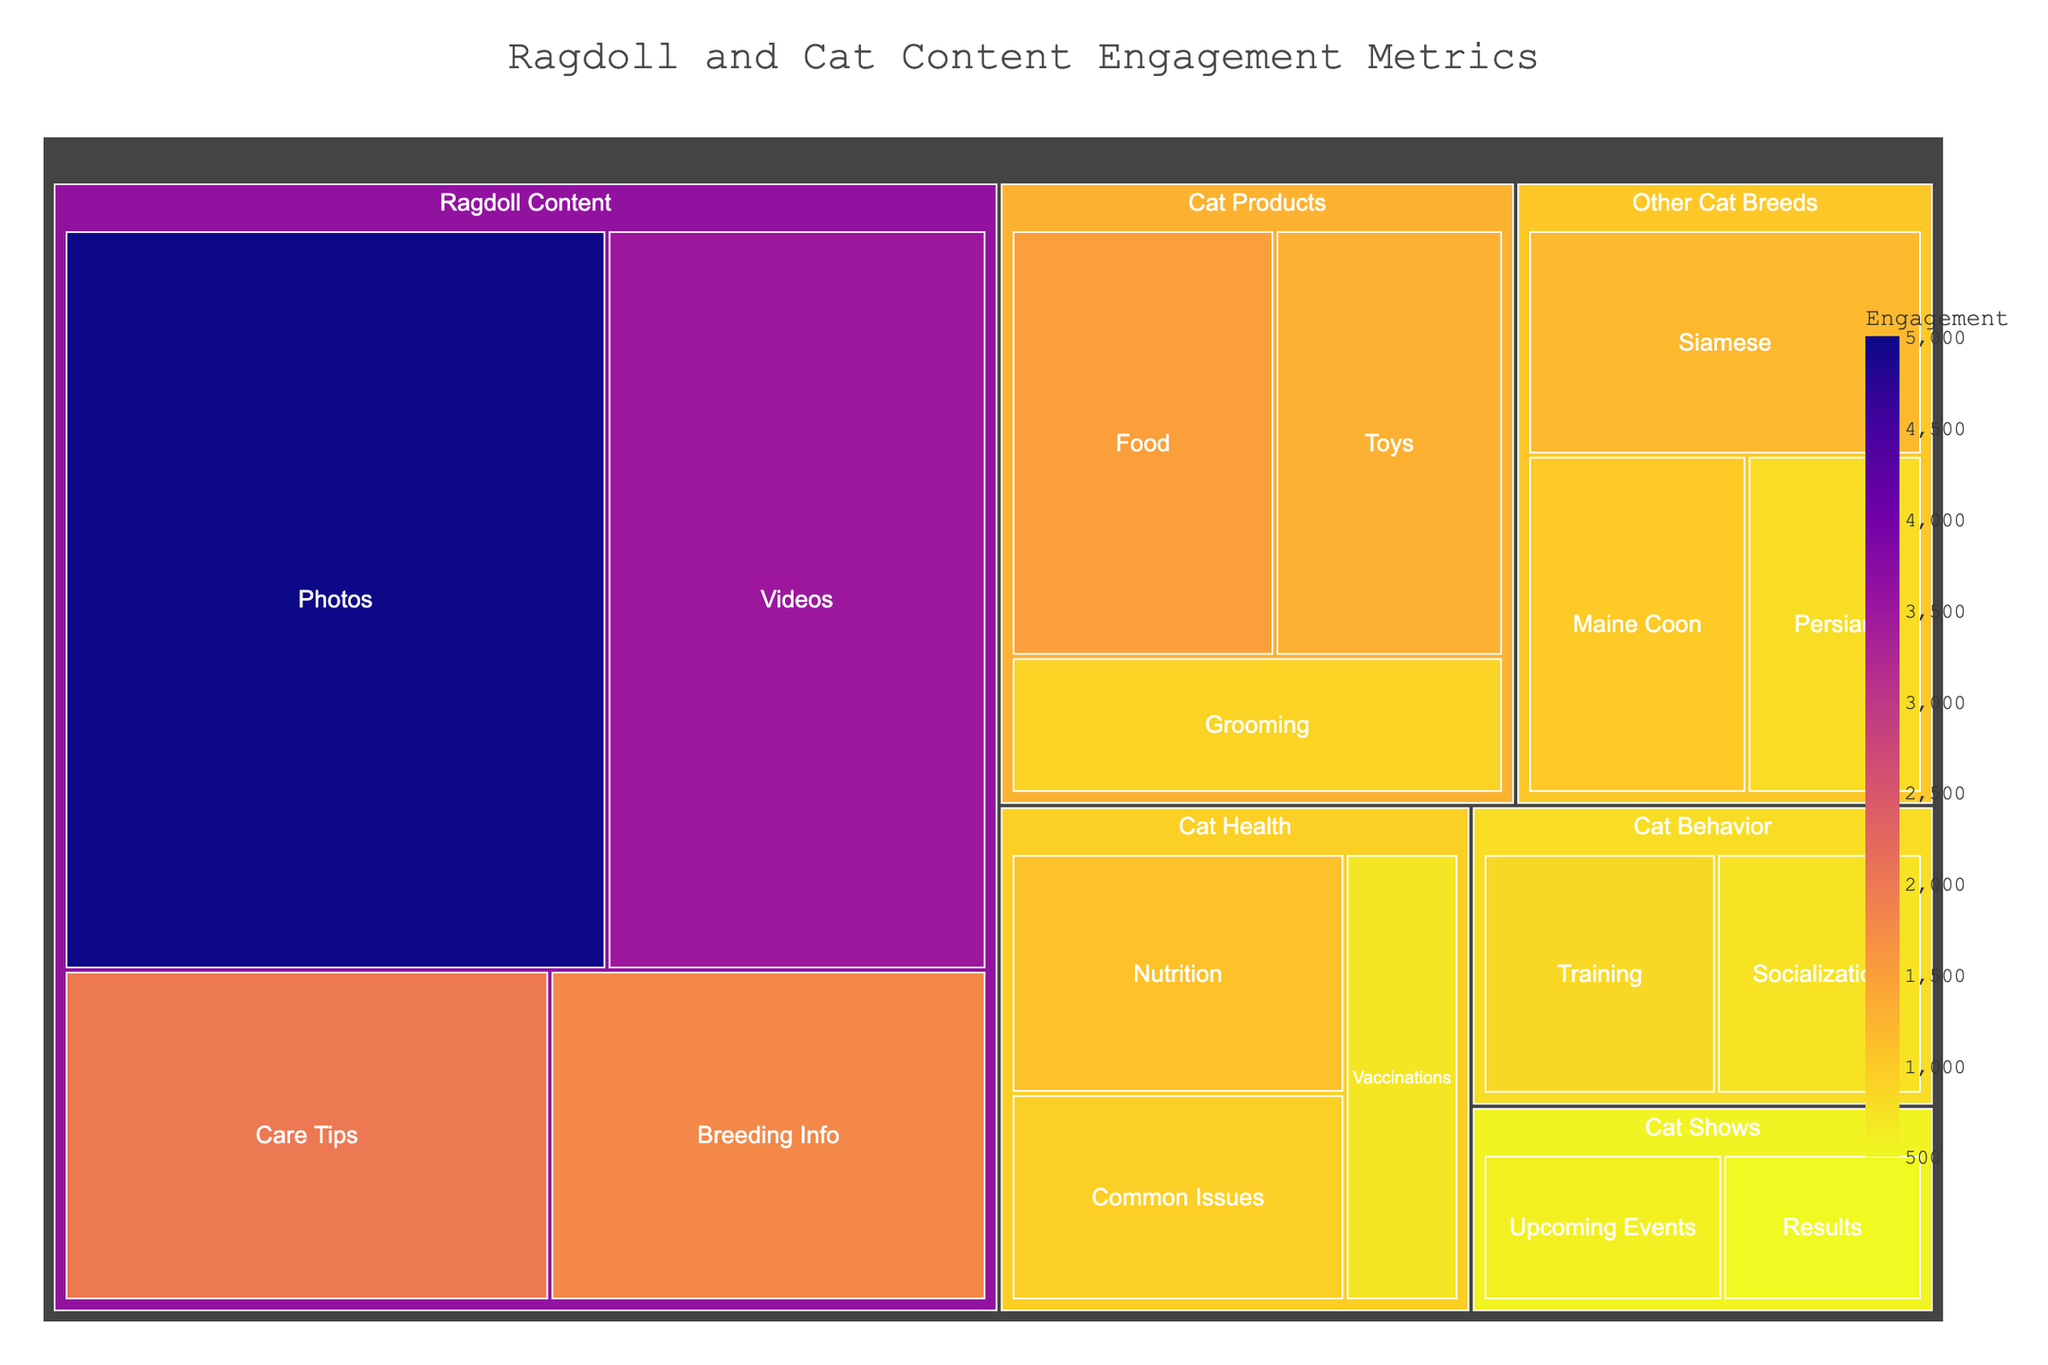What is the title of the Treemap? The title is displayed at the top of the treemap, usually in a larger font to attract attention.
Answer: Ragdoll and Cat Content Engagement Metrics Which subcategory under "Ragdoll Content" has the highest engagement? Look for the largest rectangle within the "Ragdoll Content" section, which visually represents the subcategory with the highest numerical value.
Answer: Photos What is the combined engagement for "Ragdoll Content"? Add the engagement values for all subcategories under "Ragdoll Content": 5000 (Photos) + 3500 (Videos) + 2000 (Care Tips) + 1800 (Breeding Info).
Answer: 12300 Which subcategory under "Cat Products" has the least engagement? Look for the smallest rectangle within the "Cat Products" section.
Answer: Grooming Is the engagement for "Ragdoll Content" greater than the total engagement for "Other Cat Breeds"? Sum the engagement for all subcategories in both "Ragdoll Content" and "Other Cat Breeds" and compare the totals. Ragdoll Content total is 12300 and Other Cat Breeds total is 1200 (Siamese) + 1000 (Maine Coon) + 800 (Persian) = 3000.
Answer: Yes Which category has the least overall engagement? Compare the summed values of engagements for all categories and find the lowest one. Sum values are: Ragdoll Content (12300), Other Cat Breeds (3000), Cat Products (3700), Cat Health (2750), Cat Behavior (1600), and Cat Shows (1100).
Answer: Cat Shows What is the average engagement for the subcategories under "Cat Health"? Calculate the average by summing the engagement values for all subcategories under "Cat Health" and divide by the number of subcategories: (1100 + 950 + 700) / 3.
Answer: 916.67 How many categories have at least one subcategory with an engagement value over 1000? Count the categories where at least one subcategory's engagement value exceeds 1000. Categories: Ragdoll Content (4), Other Cat Breeds (1), Cat Products (1), Cat Health (1).
Answer: 4 Which has a higher engagement, "Other Cat Breeds" or "Cat Behavior"? Compare the summed engagement values of the two categories. "Other Cat Breeds" has 1200 + 1000 + 800 = 3000, and "Cat Behavior" has 850 + 750 = 1600.
Answer: Other Cat Breeds What is the engagement difference between the most and least engaging subcategories under "Ragdoll Content"? Subtract the engagement of the least engaging subcategory (Breeding Info, 1800) from the most engaging subcategory (Photos, 5000).
Answer: 3200 